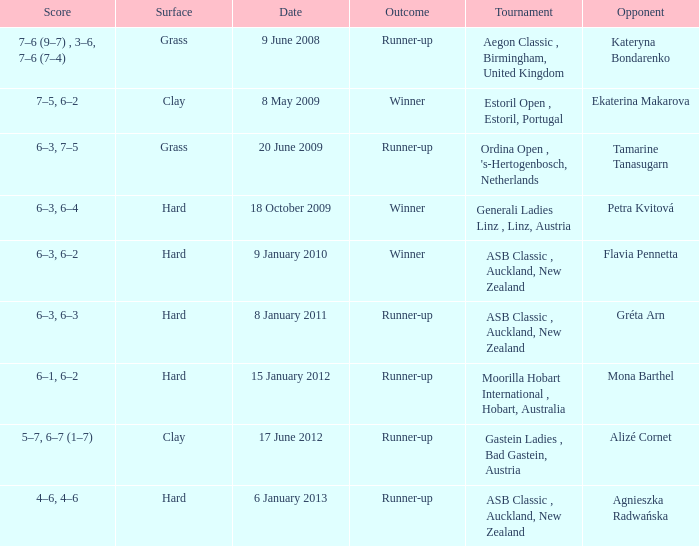In the tournament, what was the final score when competing against ekaterina makarova? 7–5, 6–2. 